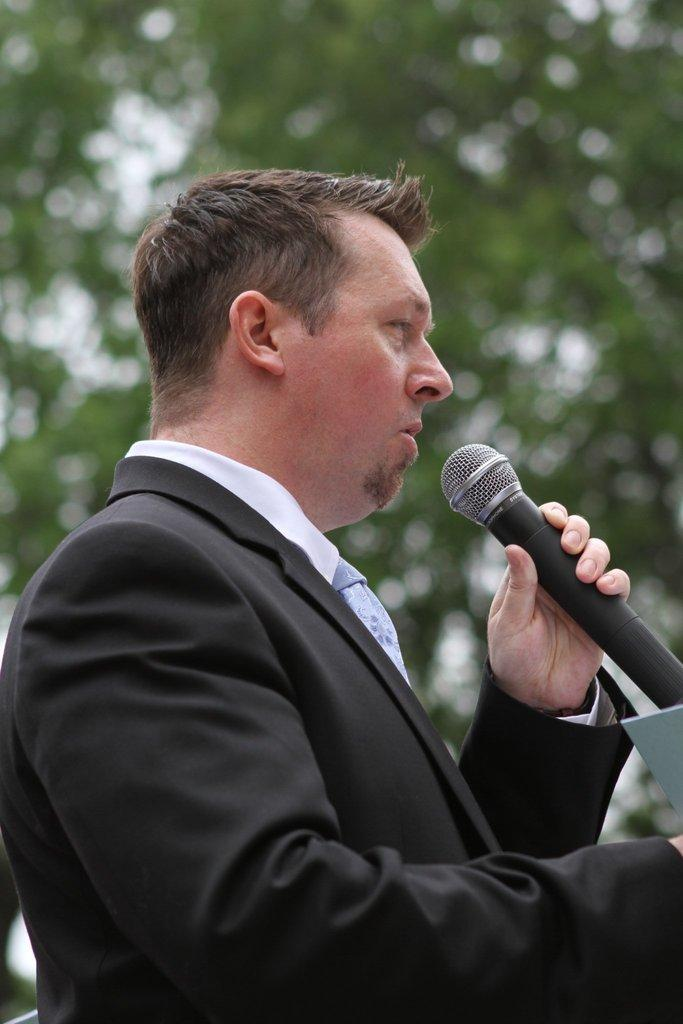What is the man wearing in the image? The man is wearing a black suit in the image. What is the man doing in the image? The man is speaking in front of a microphone and holding a microphone in the image. What can be seen in the background of the image? There is a tree visible in the background of the image. What type of vegetable is the man using as a prop while speaking in the image? There is no vegetable present in the image; the man is holding and speaking into a microphone. What drug is the man taking while speaking in the image? There is no indication of any drug use in the image; the man is simply speaking into a microphone. 